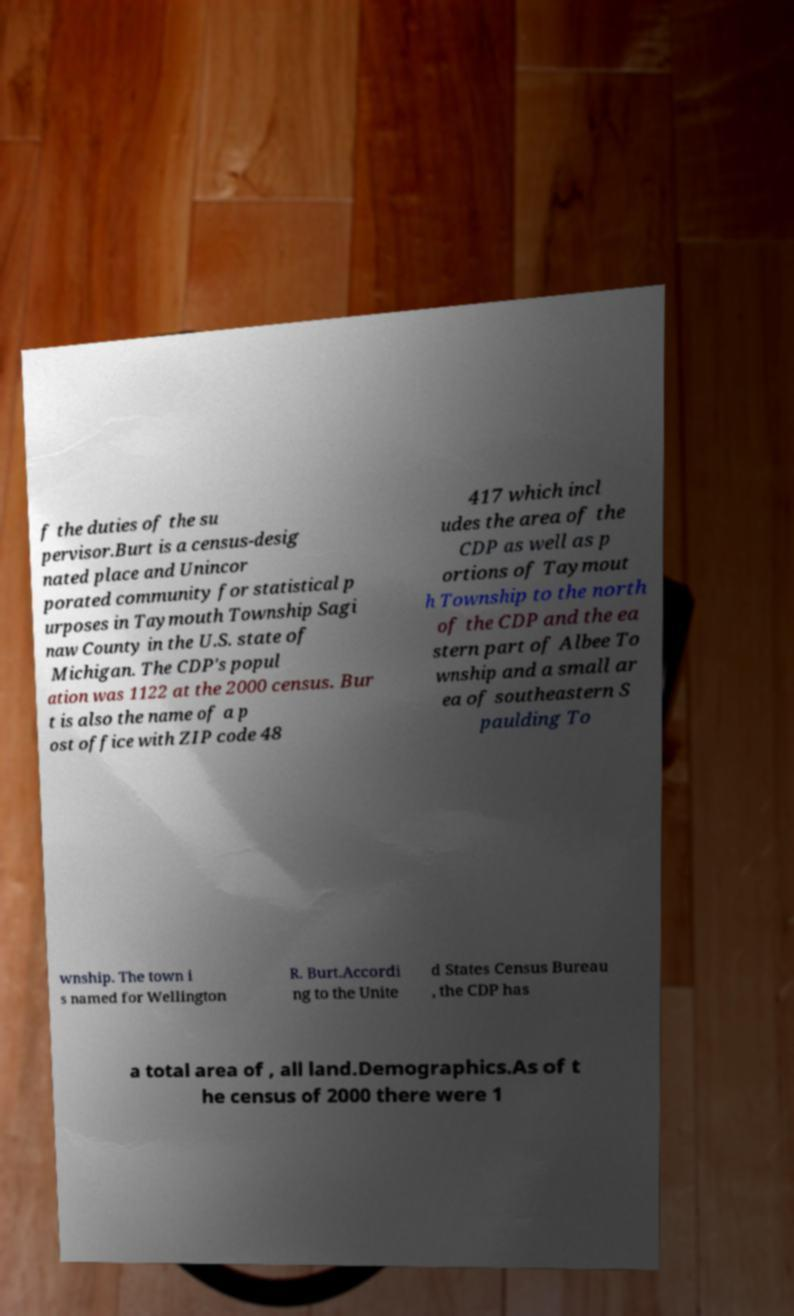Please identify and transcribe the text found in this image. f the duties of the su pervisor.Burt is a census-desig nated place and Unincor porated community for statistical p urposes in Taymouth Township Sagi naw County in the U.S. state of Michigan. The CDP's popul ation was 1122 at the 2000 census. Bur t is also the name of a p ost office with ZIP code 48 417 which incl udes the area of the CDP as well as p ortions of Taymout h Township to the north of the CDP and the ea stern part of Albee To wnship and a small ar ea of southeastern S paulding To wnship. The town i s named for Wellington R. Burt.Accordi ng to the Unite d States Census Bureau , the CDP has a total area of , all land.Demographics.As of t he census of 2000 there were 1 